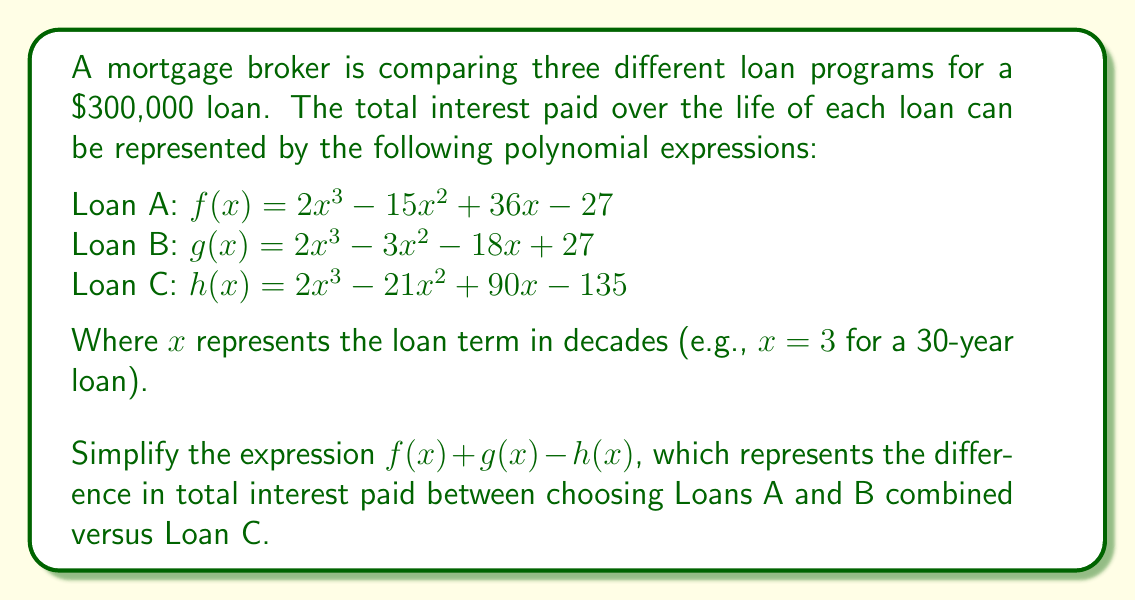Give your solution to this math problem. Let's approach this step-by-step:

1) First, we need to add $f(x)$ and $g(x)$:

   $f(x) + g(x) = (2x^3 - 15x^2 + 36x - 27) + (2x^3 - 3x^2 - 18x + 27)$

2) Combining like terms:

   $f(x) + g(x) = 4x^3 - 18x^2 + 18x + 0$

3) Now, we need to subtract $h(x)$ from this result:

   $(f(x) + g(x)) - h(x) = (4x^3 - 18x^2 + 18x + 0) - (2x^3 - 21x^2 + 90x - 135)$

4) When subtracting polynomials, we subtract the coefficients of like terms:

   $4x^3 - 18x^2 + 18x + 0$
   $-(2x^3 - 21x^2 + 90x - 135)$
   $= 2x^3 + 3x^2 - 72x + 135$

5) This is our simplified expression. However, we can factor it further:

   $2x^3 + 3x^2 - 72x + 135$
   $= (x^2 + 18)(2x - 5) + 225$
   $= (x^2 + 18)(2x - 5) + 9^2$

6) Therefore, the fully factored form is:

   $(x^2 + 18)(2x - 5) + 9^2$

This represents the difference in total interest paid between choosing Loans A and B combined versus Loan C, expressed as a function of the loan term in decades.
Answer: $(x^2 + 18)(2x - 5) + 9^2$ 